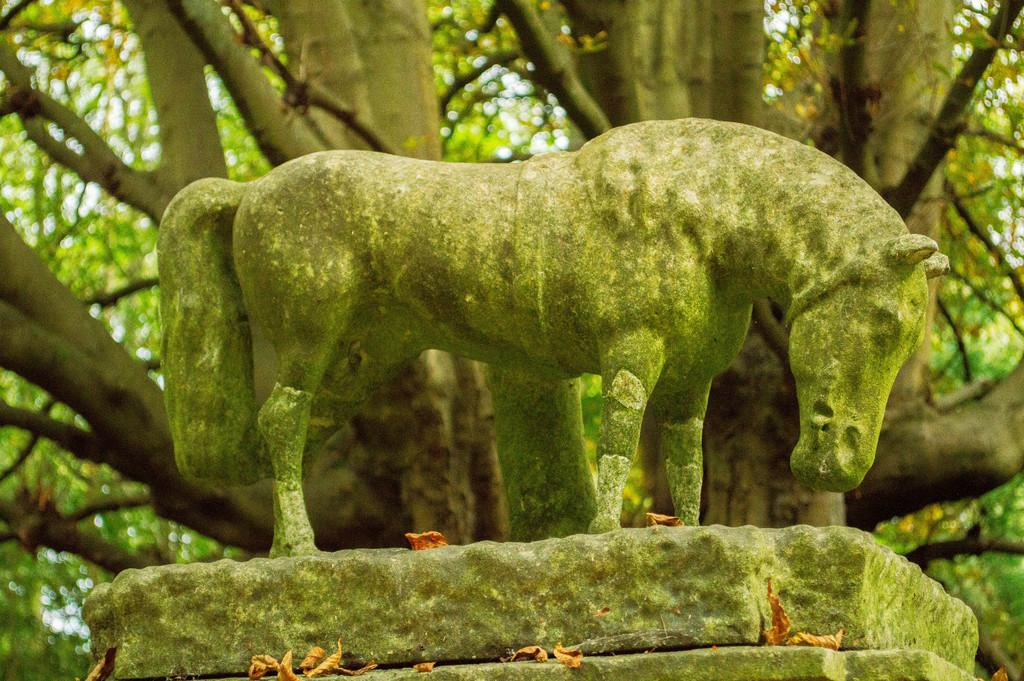What is the main subject of the image? There is a statue in the image. How is the statue positioned in the image? The statue is on a pedestal. What type of vegetation can be seen in the image? There are trees in the image. What is visible in the background of the image? The sky is visible in the image. Can you tell me how many wires are attached to the statue in the image? There are no wires attached to the statue in the image. What type of badge is the statue wearing in the image? The statue is not wearing a badge in the image. 